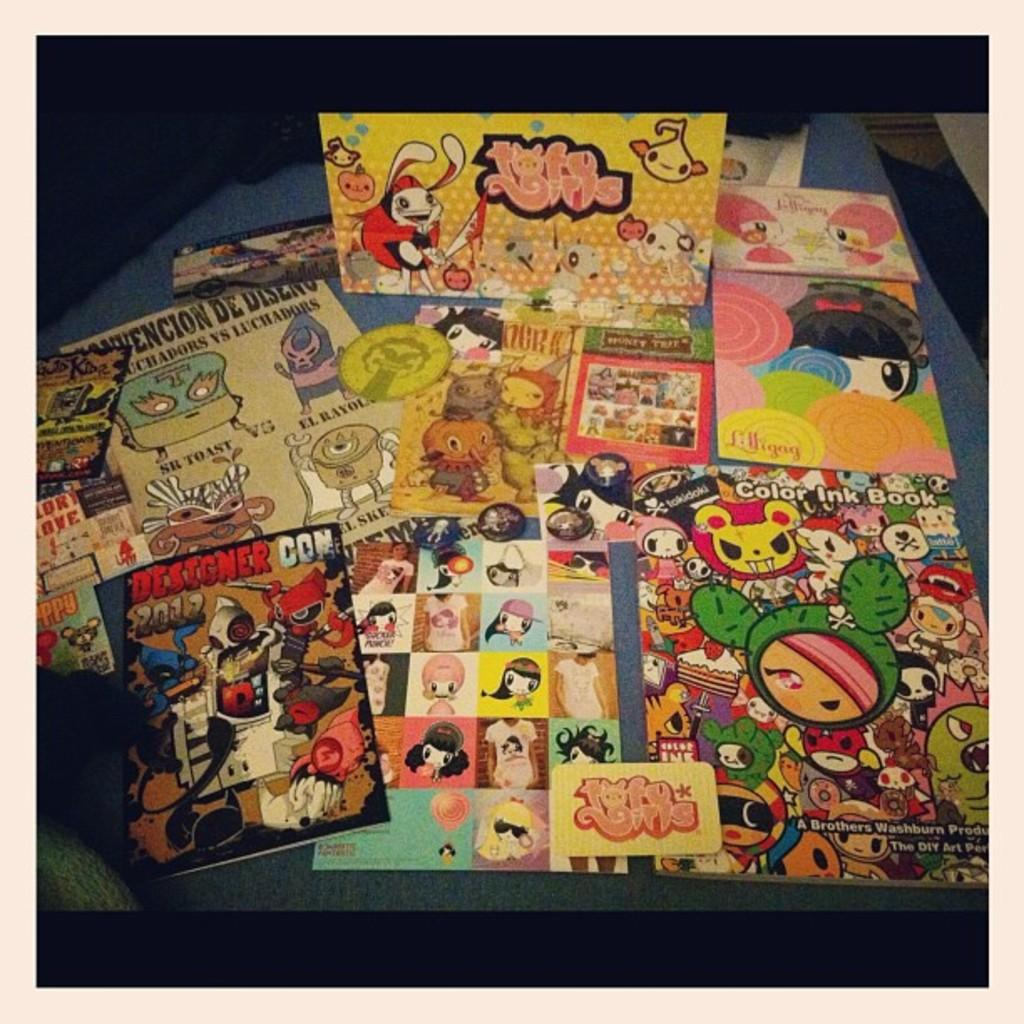<image>
Present a compact description of the photo's key features. A Color Ink Book lays on the bottom right corner of a table. 